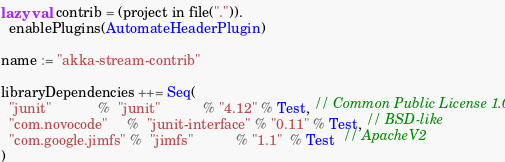Convert code to text. <code><loc_0><loc_0><loc_500><loc_500><_Scala_>lazy val contrib = (project in file(".")).
  enablePlugins(AutomateHeaderPlugin)

name := "akka-stream-contrib"

libraryDependencies ++= Seq(
  "junit"            %  "junit"           % "4.12" % Test, // Common Public License 1.0
  "com.novocode"     %  "junit-interface" % "0.11" % Test, // BSD-like
  "com.google.jimfs" %  "jimfs"           % "1.1"  % Test  // ApacheV2
)
</code> 